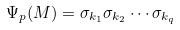<formula> <loc_0><loc_0><loc_500><loc_500>\Psi _ { p } ( M ) = \sigma _ { k _ { 1 } } \sigma _ { k _ { 2 } } \cdots \sigma _ { k _ { q } }</formula> 